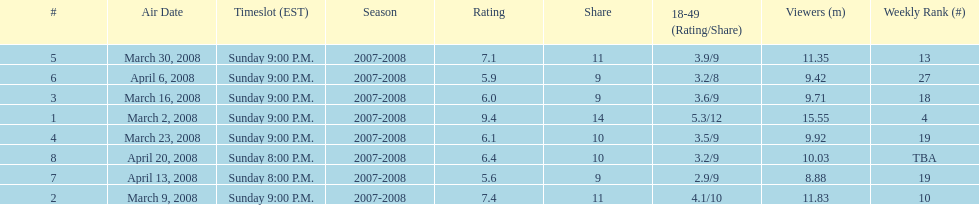How many shows had at least 10 million viewers? 4. 